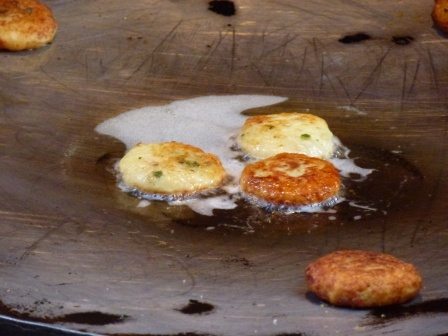Can you describe the main features of this image for me? The image captures an exciting moment in the kitchen where five pancakes are sizzling in a black frying pan, glistening with oil. The pan is placed on a stovetop with a black burner in view. The pancakes are at various stages of cooking, presenting a mouthwatering golden-brown hue, with bits of green likely from chives sprinkled within them.

Among the five, the pancake on the left stands out as it is the largest and boasts a deep golden brown, possibly benefiting from an optimal spot in the pan. On the right, four pancakes are arranged more closely together in a loose square configuration. The center pancake in this group looks lighter than the others, suggesting it needs more cooking time to reach a uniform golden brown shade. The scene overall evokes a sense of anticipation for a delicious meal in progress, with each pancake contributing its unique texture and flavor. 